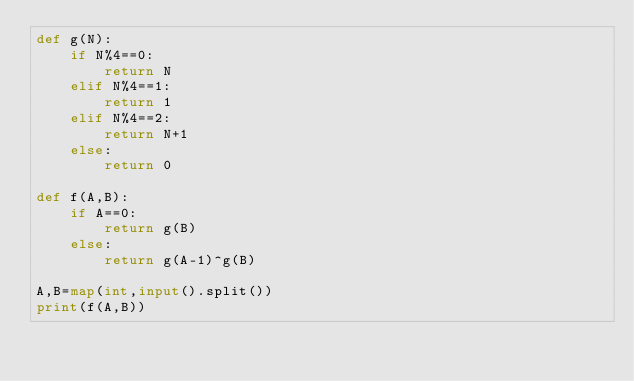<code> <loc_0><loc_0><loc_500><loc_500><_Python_>def g(N):
    if N%4==0:
        return N
    elif N%4==1:
        return 1
    elif N%4==2:
        return N+1
    else:
        return 0

def f(A,B):
    if A==0:
        return g(B)
    else:
        return g(A-1)^g(B)

A,B=map(int,input().split())
print(f(A,B))</code> 